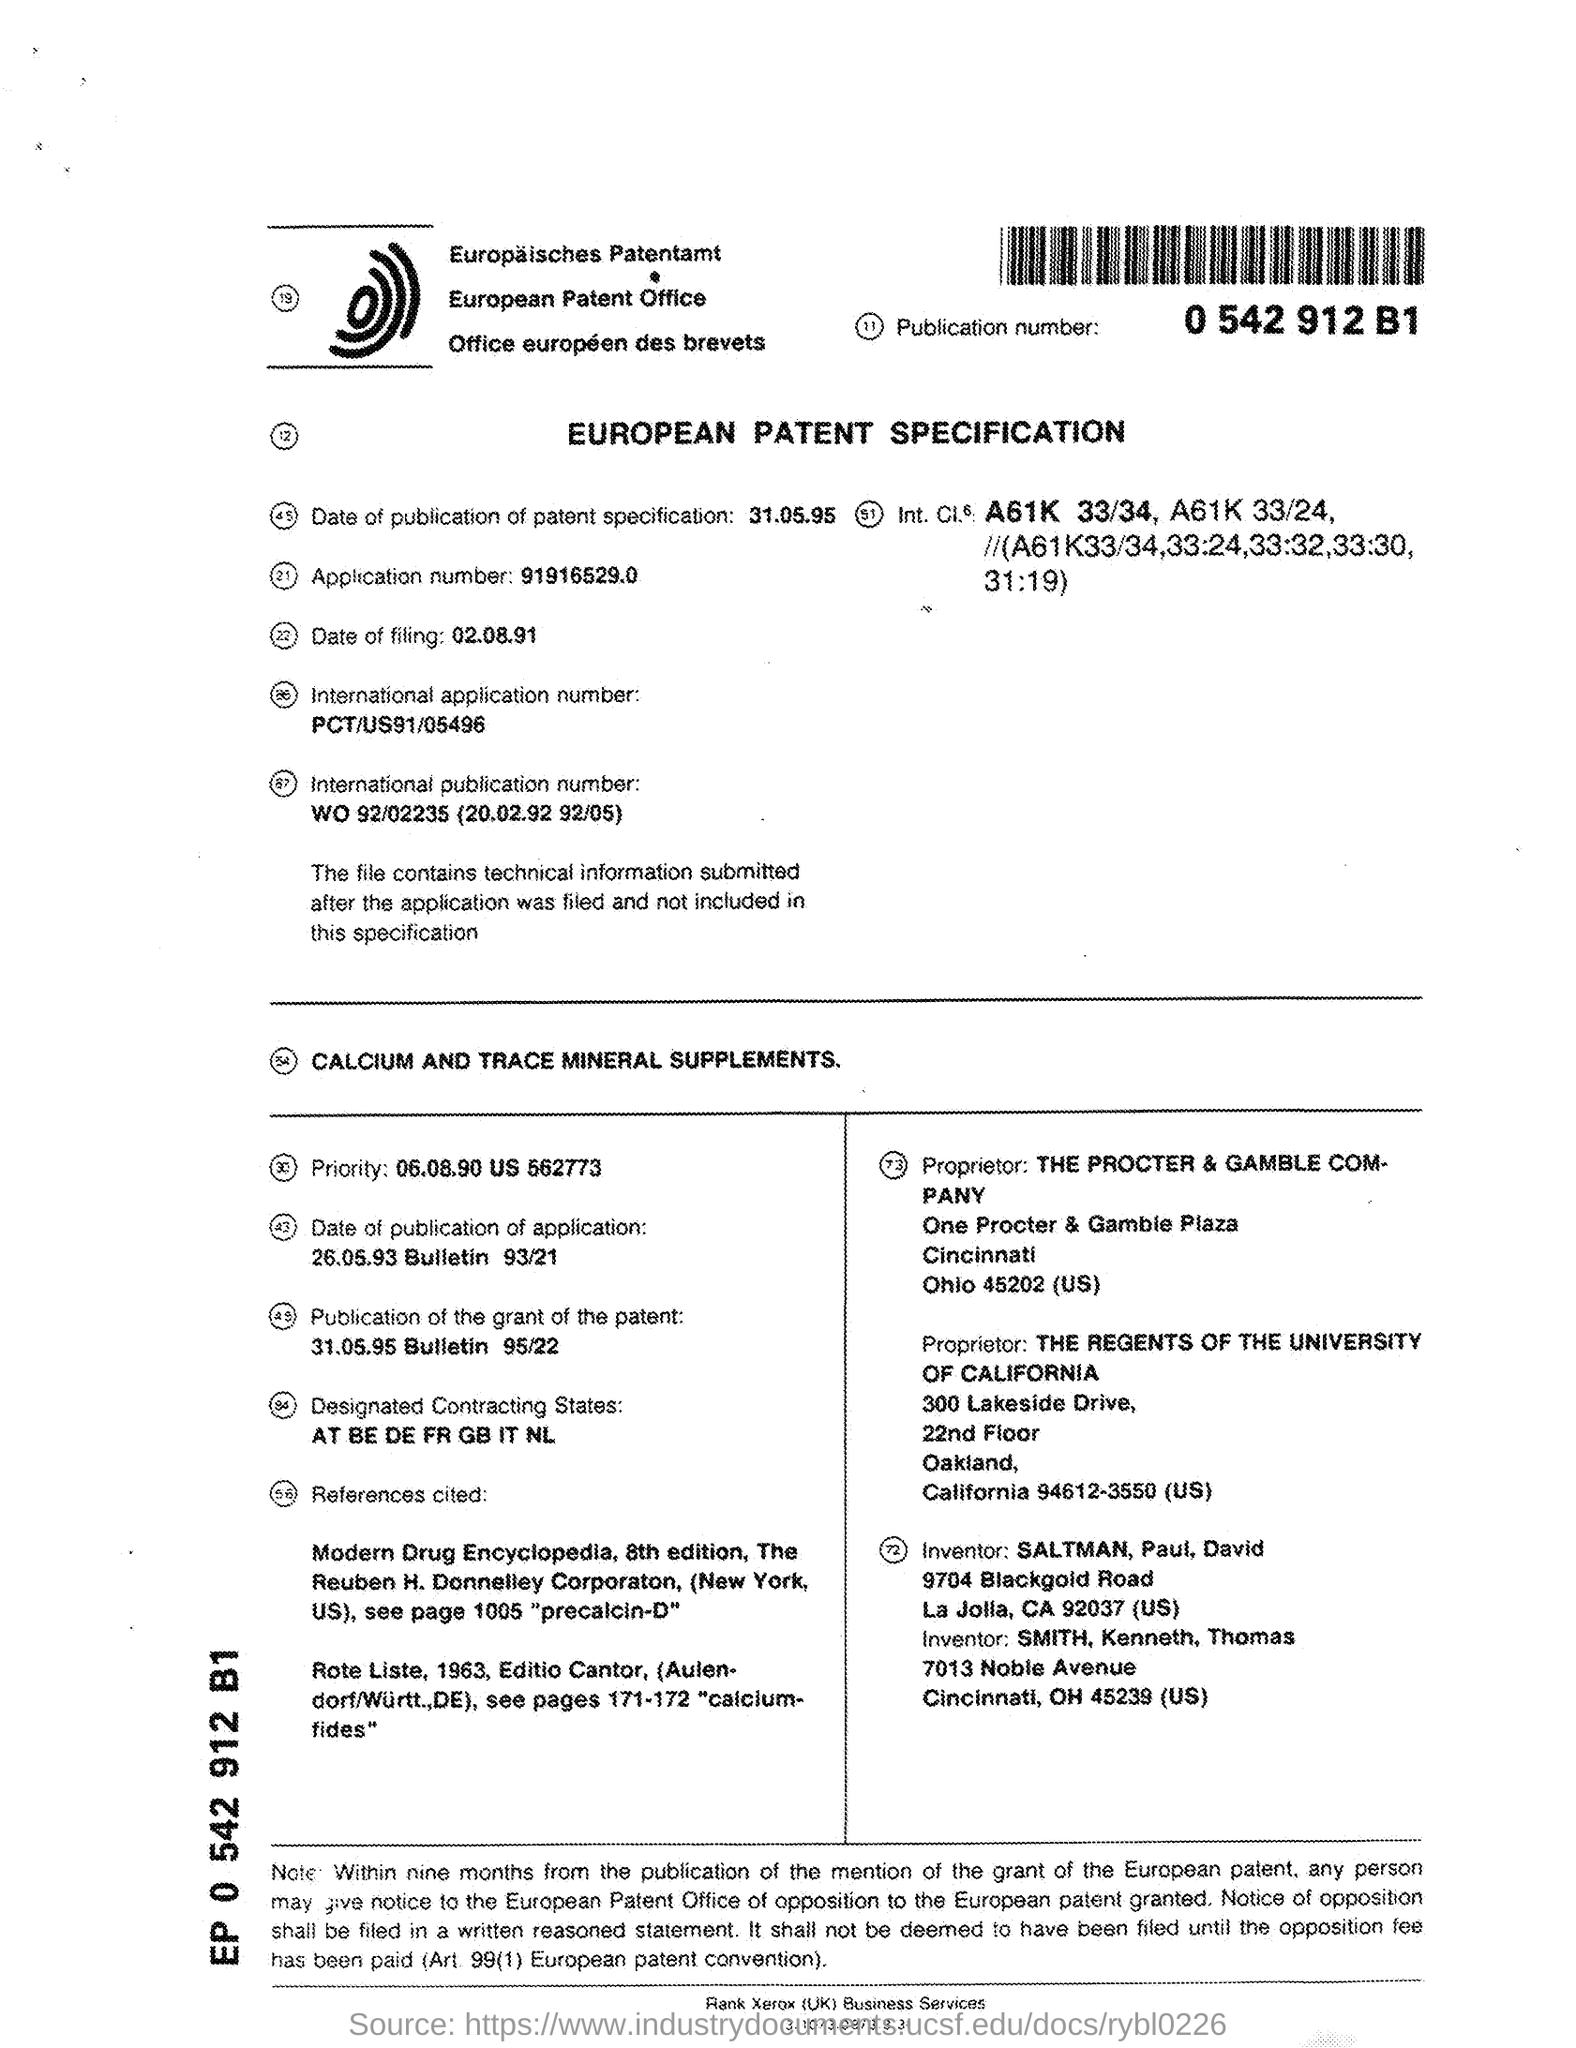What is the Publication Number?
Ensure brevity in your answer.  0 542 912 B1. What is the Title of the Document?
Give a very brief answer. EUROPEAN PATENT SPECIFICATION. What is the Date of publication of Patent specification?
Ensure brevity in your answer.  31.05.95. What is the Application Number?
Give a very brief answer. 91916529.0. When is the Date of Filing?
Ensure brevity in your answer.  02.08.91. What is the International Application Number?
Give a very brief answer. PCT/US91/05496. What is the Publication of Grant of the patent?
Provide a short and direct response. 31.05.95 Bulletin 95/22. Who is the Inventor?
Ensure brevity in your answer.  SALTMAN, Paul, David. 